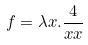Convert formula to latex. <formula><loc_0><loc_0><loc_500><loc_500>f = \lambda x . \frac { 4 } { x x }</formula> 